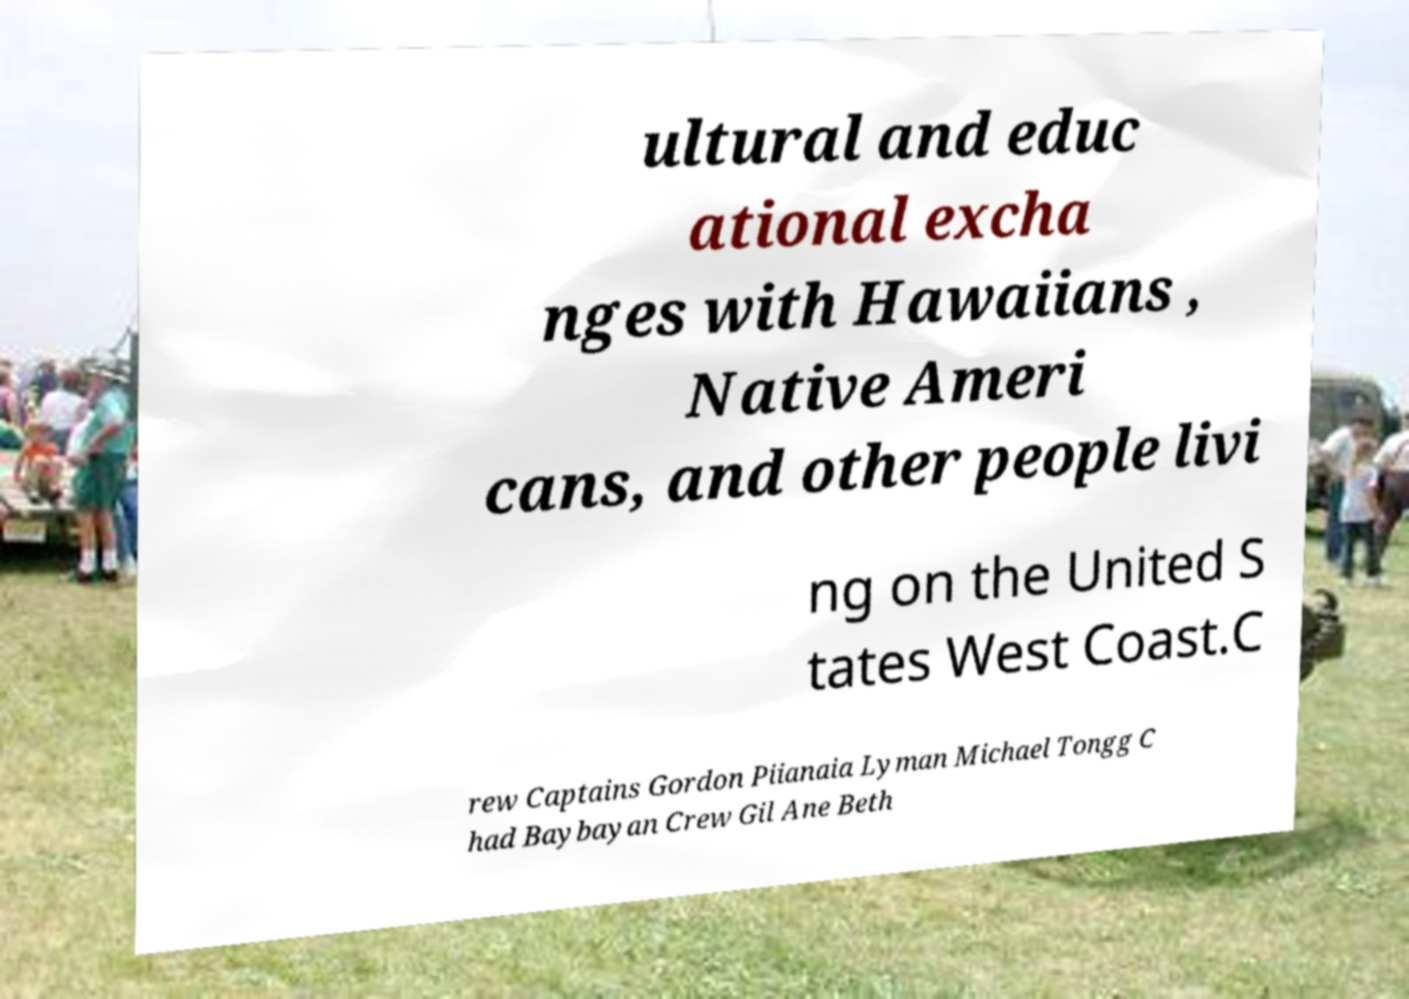Can you read and provide the text displayed in the image?This photo seems to have some interesting text. Can you extract and type it out for me? ultural and educ ational excha nges with Hawaiians , Native Ameri cans, and other people livi ng on the United S tates West Coast.C rew Captains Gordon Piianaia Lyman Michael Tongg C had Baybayan Crew Gil Ane Beth 